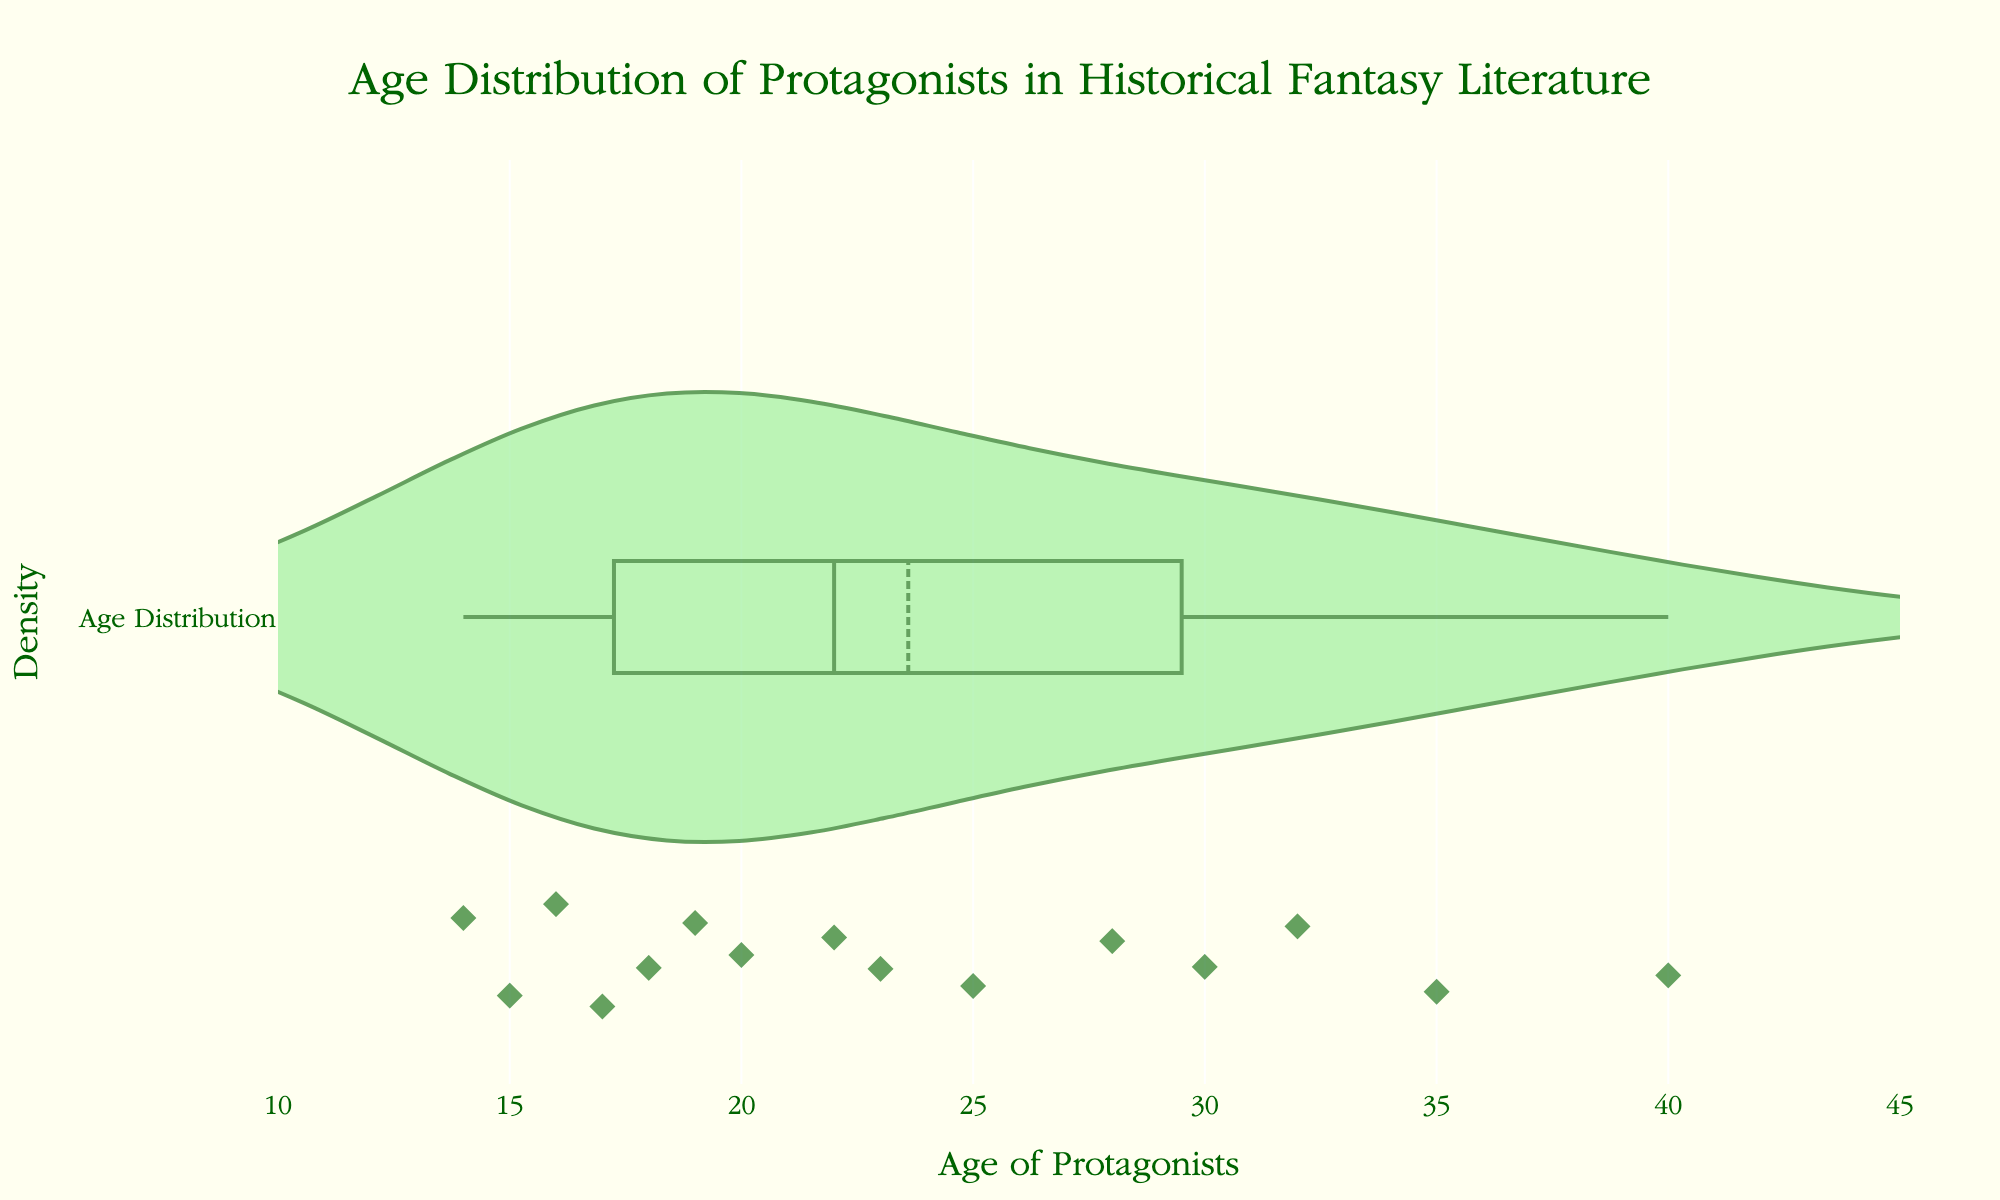What is the title of the plot? The title of the plot is usually located at the top of the figure. The title reads "Age Distribution of Protagonists in Historical Fantasy Literature".
Answer: Age Distribution of Protagonists in Historical Fantasy Literature How many distinct ages are represented in the plot? By observing the x-axis and the individual points in the plot, we can count the distinct ages of the protagonists. Each unique x value represents a distinct age.
Answer: 14 What is the color used for the violin plot and the data points? The visual plot shows the violin plot filling in with light green and the data points marked in dark green.
Answer: light green (fill), dark green (points) What age range does the x-axis cover? The x-axis shows age intervals starting from 10 up to 45. This range is represented through the tick marks and labels along the x-axis.
Answer: 10 to 45 Which age of protagonists appears the most frequently in the dataset? Inspecting the density plot, the top of the violin plot is the area where most of the data points cluster, revealing the mode.
Answer: 16 What is the average age of protagonists in this dataset? Calculate the mean of the ages given: (16 + 23 + 18 + 32 + 14 + 28 + 20 + 35 + 17 + 25 + 30 + 19 + 40 + 22 + 15)/15 = 24.33.
Answer: 24.33 How does the age distribution of protagonists trend with respect to historical elements in fantasy literature? By analyzing the shape of the violin plot, the age distribution appears to be skewed slightly towards younger ages and shows a spread from mid-teens to mid-thirties, with some outliers towards the higher ages.
Answer: Skewed towards younger ages, spread from mid-teens to mid-thirties What is the median age of protagonists in this dataset? To find the median, order the ages and find the middle value. Ordered ages: 14, 15, 16, 17, 18, 19, 20, 22, 23, 25, 28, 30, 32, 35, 40. Middle value: 22.
Answer: 22 Compare the representation of protagonists aged 20 and below to those aged above 30. Which group is larger? Count the number of data points for protagonists aged 20 and below and those aged above 30. Ages ≤ 20: 6 (14, 15, 16, 17, 18, 19). Ages > 30: 5 (32, 35, 40, 28, 30).
Answer: 20 and below 